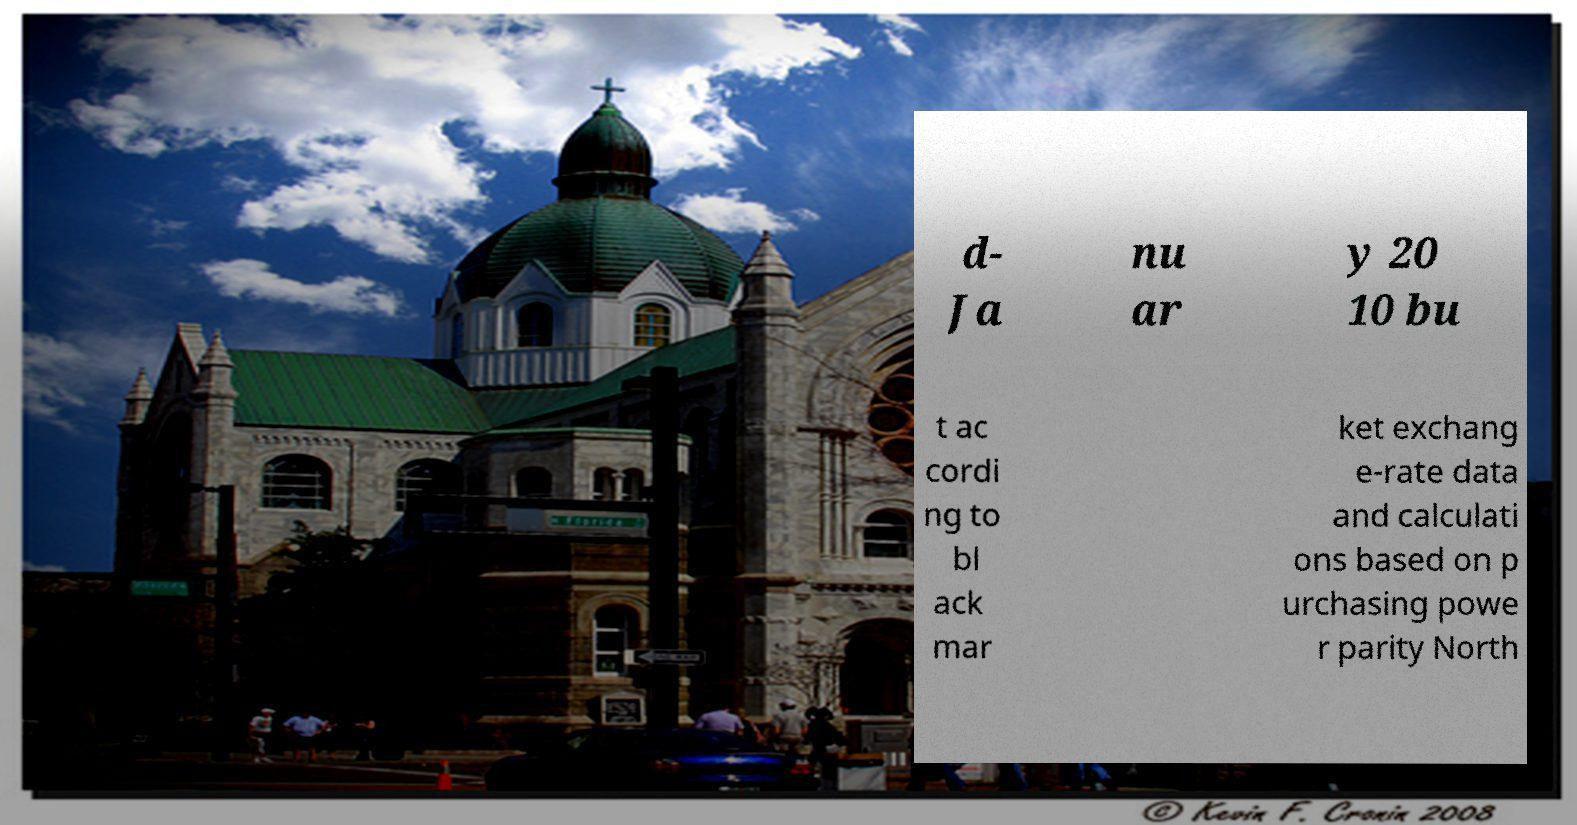Please identify and transcribe the text found in this image. d- Ja nu ar y 20 10 bu t ac cordi ng to bl ack mar ket exchang e-rate data and calculati ons based on p urchasing powe r parity North 